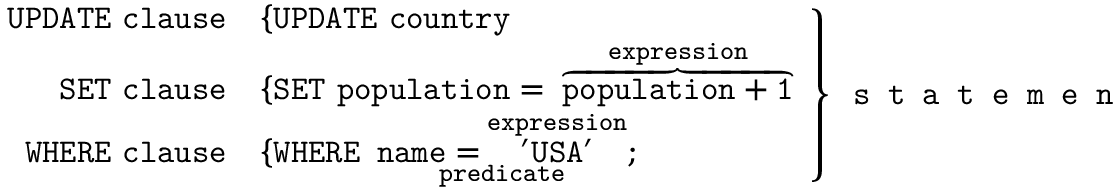<formula> <loc_0><loc_0><loc_500><loc_500>{ \begin{array} { r l } { U P D A T E c l a u s e } & { \{ U P D A T E \ c o u n t r y } \\ { S E T c l a u s e } & { \{ { S E T \ p o p u l a t i o n = } \overbrace { p o p u l a t i o n + 1 } ^ { e x p r e s s i o n } } \\ { W H E R E c l a u s e } & { \{ { W H E R E \ \underbrace { { n a m e = } \overbrace { ^ { \prime } U S A ^ { \prime } } ^ { e x p r e s s i o n } } _ { p r e d i c a t e } ; } } \end{array} } \right \} { s t a t e m e n t }</formula> 